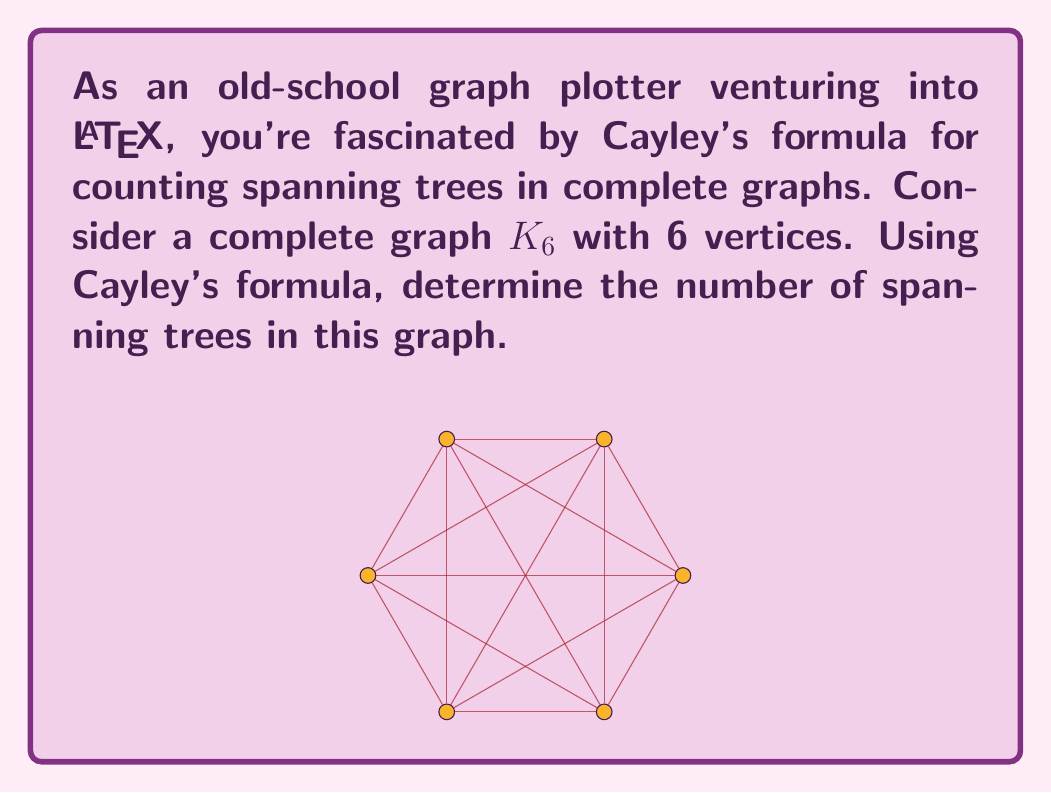Solve this math problem. Let's approach this step-by-step:

1) Recall Cayley's formula for the number of spanning trees in a complete graph:

   For a complete graph with $n$ vertices, the number of spanning trees is $n^{n-2}$

2) In our case, we have a complete graph $K_6$, so $n = 6$

3) Plugging this into the formula:

   Number of spanning trees = $6^{6-2} = 6^4$

4) Now, let's calculate $6^4$:
   
   $6^4 = 6 \times 6 \times 6 \times 6 = 1296$

Therefore, the complete graph $K_6$ has 1296 spanning trees.
Answer: $1296$ 